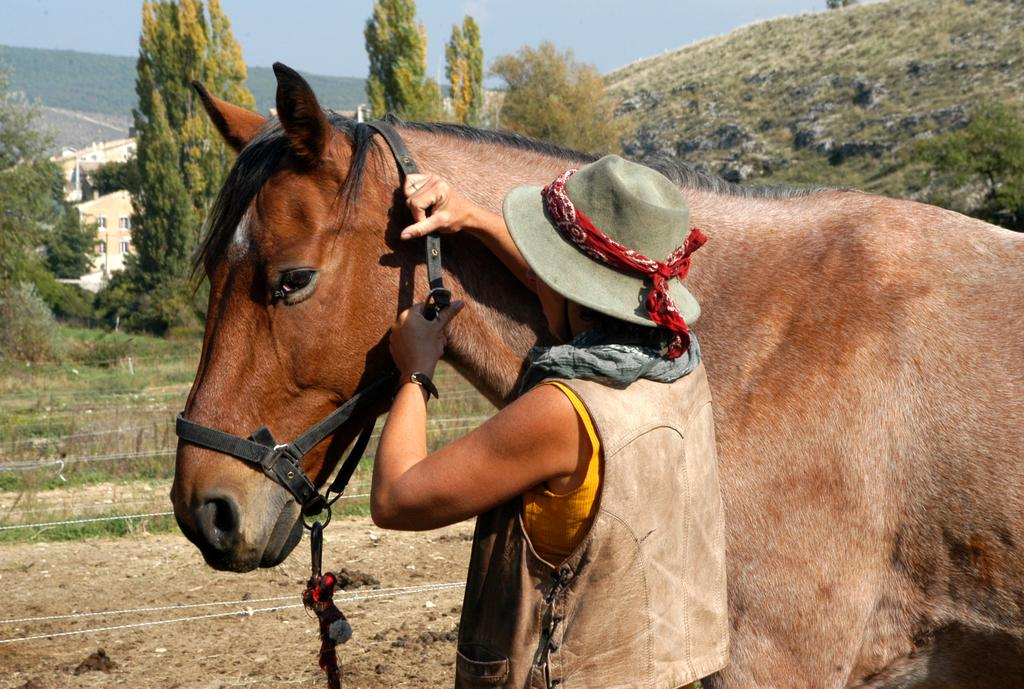What type of animal is in the image? There is a horse in the image. Who or what else is in the image? There is a person in the image. What natural feature can be seen in the background? There is a mountain visible in the image. What type of vegetation is present in the image? There are trees in the image. What type of agreement is being signed by the horse and the person in the image? There is no agreement being signed in the image, as it features a horse and a person in a natural setting with a mountain and trees. 